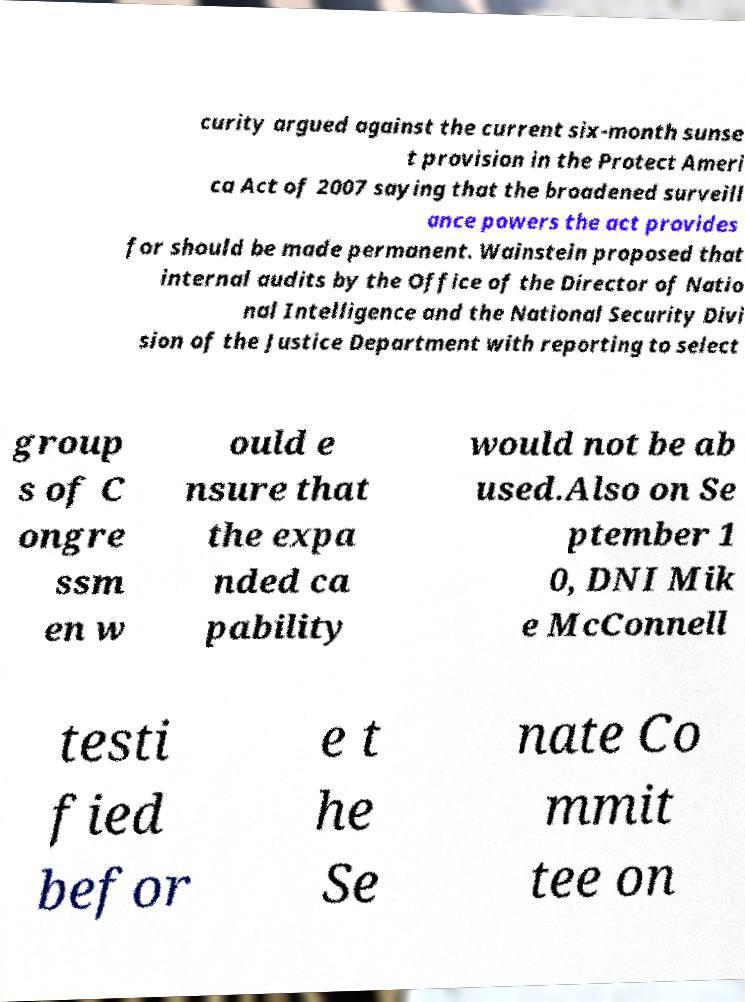Please identify and transcribe the text found in this image. curity argued against the current six-month sunse t provision in the Protect Ameri ca Act of 2007 saying that the broadened surveill ance powers the act provides for should be made permanent. Wainstein proposed that internal audits by the Office of the Director of Natio nal Intelligence and the National Security Divi sion of the Justice Department with reporting to select group s of C ongre ssm en w ould e nsure that the expa nded ca pability would not be ab used.Also on Se ptember 1 0, DNI Mik e McConnell testi fied befor e t he Se nate Co mmit tee on 